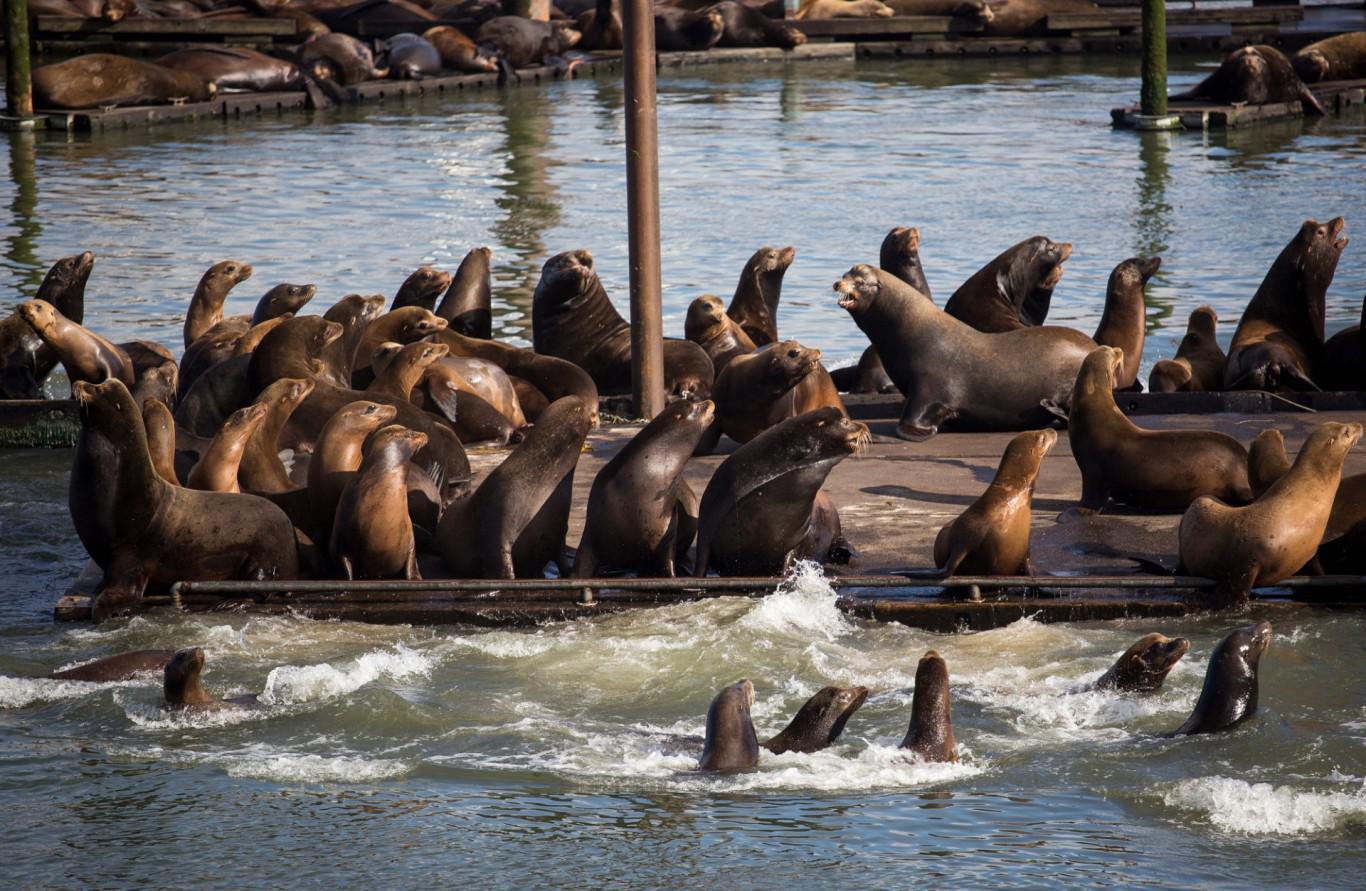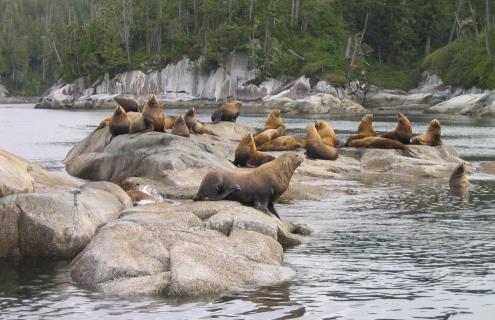The first image is the image on the left, the second image is the image on the right. Evaluate the accuracy of this statement regarding the images: "All seals in the right image are out of the water.". Is it true? Answer yes or no. No. The first image is the image on the left, the second image is the image on the right. Given the left and right images, does the statement "Both images show masses of seals on natural rock formations above the water." hold true? Answer yes or no. No. 